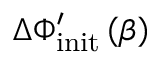Convert formula to latex. <formula><loc_0><loc_0><loc_500><loc_500>\Delta \Phi _ { i n i t } ^ { \prime } \left ( \beta \right )</formula> 